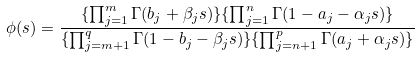Convert formula to latex. <formula><loc_0><loc_0><loc_500><loc_500>\phi ( s ) = \frac { \{ \prod _ { j = 1 } ^ { m } \Gamma ( b _ { j } + \beta _ { j } s ) \} \{ \prod _ { j = 1 } ^ { n } \Gamma ( 1 - a _ { j } - \alpha _ { j } s ) \} } { \{ \prod _ { j = m + 1 } ^ { q } \Gamma ( 1 - b _ { j } - \beta _ { j } s ) \} \{ \prod _ { j = n + 1 } ^ { p } \Gamma ( a _ { j } + \alpha _ { j } s ) \} }</formula> 